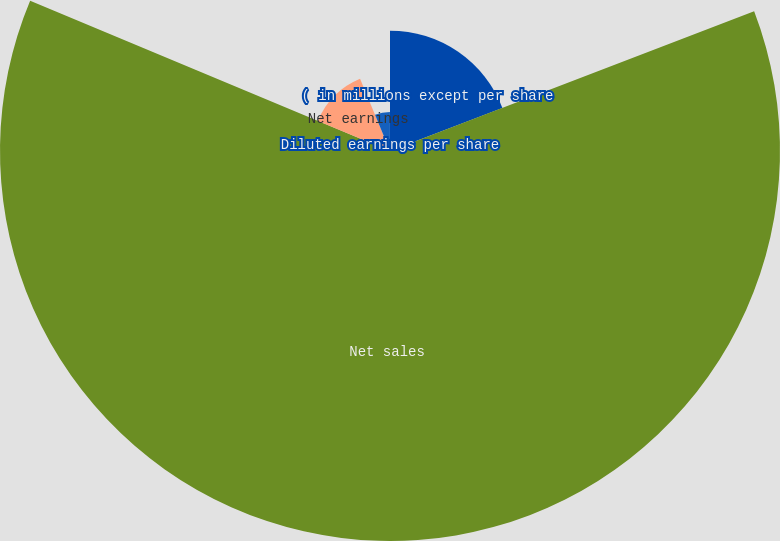Convert chart to OTSL. <chart><loc_0><loc_0><loc_500><loc_500><pie_chart><fcel>( in millions except per share<fcel>Net sales<fcel>Net earnings<fcel>Basic earnings per share<fcel>Diluted earnings per share<nl><fcel>19.17%<fcel>62.12%<fcel>12.44%<fcel>6.23%<fcel>0.03%<nl></chart> 